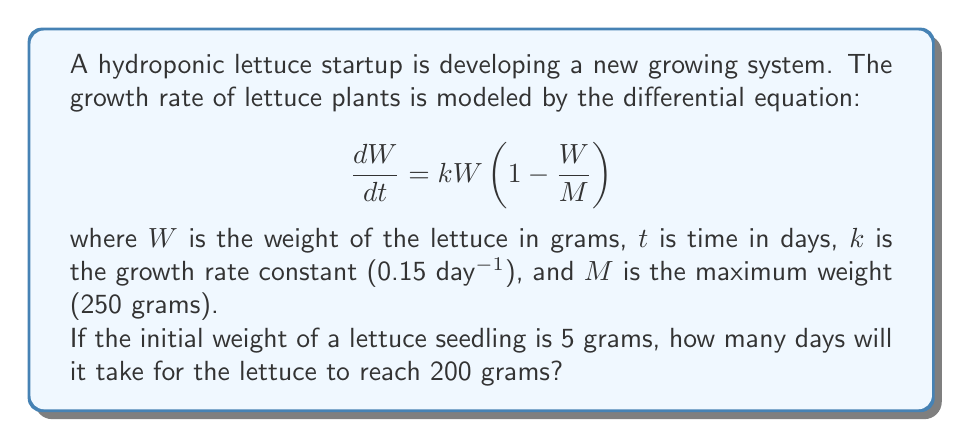Can you answer this question? To solve this problem, we need to use the given logistic growth differential equation and integrate it to find the time required for the lettuce to reach 200 grams.

1. First, let's separate the variables in the differential equation:

   $$\frac{dW}{W(1 - \frac{W}{M})} = k dt$$

2. Integrate both sides:

   $$\int_{W_0}^{W} \frac{dW}{W(1 - \frac{W}{M})} = \int_{0}^{t} k dt$$

3. The left-hand side can be integrated using partial fractions:

   $$\left[\ln|W| - \ln|M-W|\right]_{W_0}^{W} = kt$$

4. Substituting the limits and simplifying:

   $$\ln\left|\frac{W}{M-W}\right| - \ln\left|\frac{W_0}{M-W_0}\right| = kt$$

5. Exponentiate both sides:

   $$\frac{W}{M-W} = \frac{W_0}{M-W_0}e^{kt}$$

6. Solve for $W$:

   $$W = \frac{MW_0e^{kt}}{M-W_0+W_0e^{kt}}$$

7. Now, let's substitute the given values:
   $W_0 = 5$ grams
   $M = 250$ grams
   $k = 0.15$ day$^{-1}$
   $W = 200$ grams (target weight)

8. Plug these values into the equation and solve for $t$:

   $$200 = \frac{250 \cdot 5 \cdot e^{0.15t}}{250-5+5e^{0.15t}}$$

9. Simplify and solve for $t$:

   $$200(250-5+5e^{0.15t}) = 1250e^{0.15t}$$
   $$50000-1000+1000e^{0.15t} = 1250e^{0.15t}$$
   $$49000 = 250e^{0.15t}$$
   $$196 = e^{0.15t}$$
   $$\ln(196) = 0.15t$$
   $$t = \frac{\ln(196)}{0.15} \approx 35.06$$

Therefore, it will take approximately 35.06 days for the lettuce to reach 200 grams.
Answer: 35.06 days 